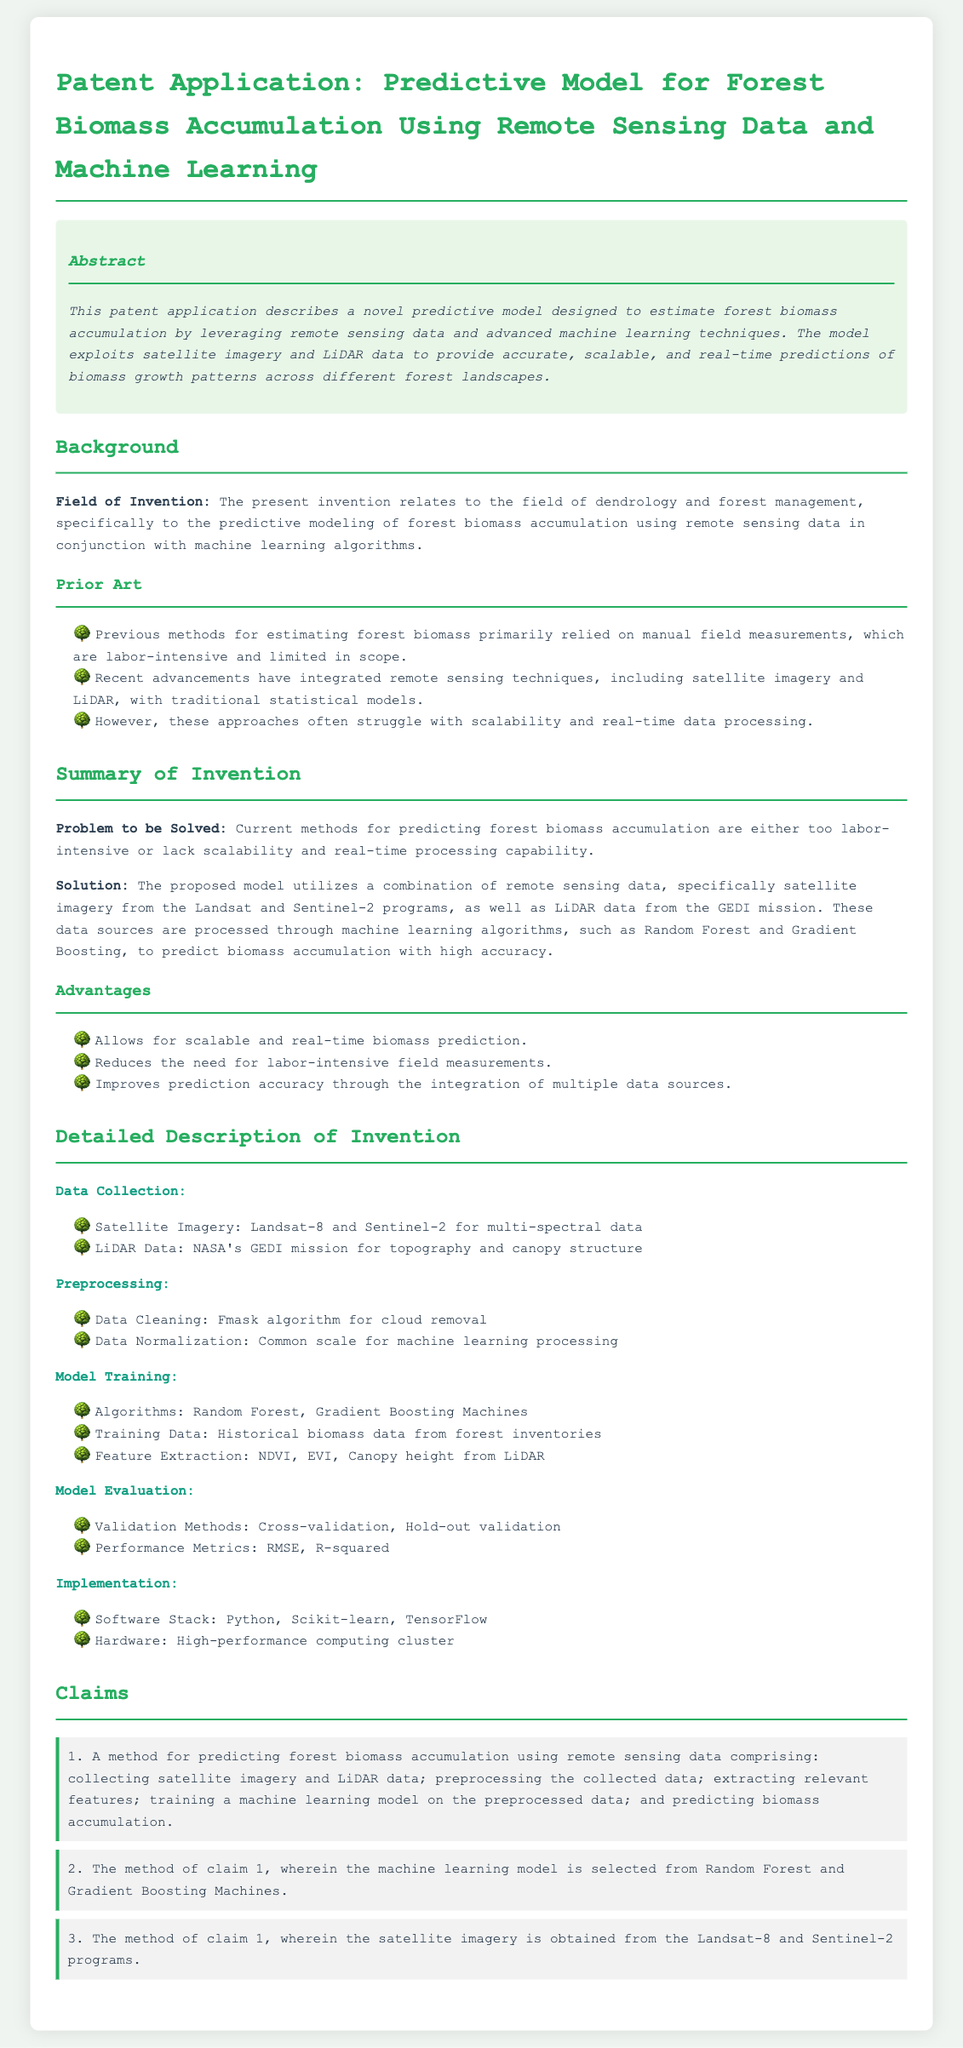what is the title of the patent application? The title of the patent application is stated at the beginning of the document.
Answer: Predictive Model for Forest Biomass Accumulation Using Remote Sensing Data and Machine Learning what technologies are combined in the proposed model? This information is presented in the summary of the invention section, specifying the combination of technologies.
Answer: Remote sensing data and machine learning techniques which algorithms are mentioned for model training? The document lists the machine learning algorithms used in the model training section.
Answer: Random Forest and Gradient Boosting Machines what is the primary issue with current biomass prediction methods? The problem being addressed can be found in the summary of the invention.
Answer: Labor-intensive or lack scalability and real-time processing capability which remote sensing data sources are utilized in the model? The summary of the invention specifies the remote sensing data sources collected.
Answer: Landsat and Sentinel-2 satellite imagery, GEDI LiDAR data what validation methods are used for model evaluation? This detail is found under the model evaluation section, outlining the approaches for validation.
Answer: Cross-validation, Hold-out validation how does the proposed model improve prediction accuracy? The advantages section explains how the model enhances accuracy through various integrations.
Answer: Integration of multiple data sources what is the software stack used for implementation? The implementation section lists the required software for model execution.
Answer: Python, Scikit-learn, TensorFlow 